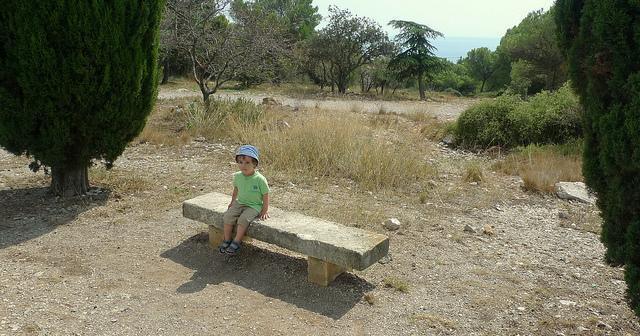How many bicycles are in the picture?
Give a very brief answer. 0. How many benches can you see?
Give a very brief answer. 1. How many elephants are there?
Give a very brief answer. 0. 